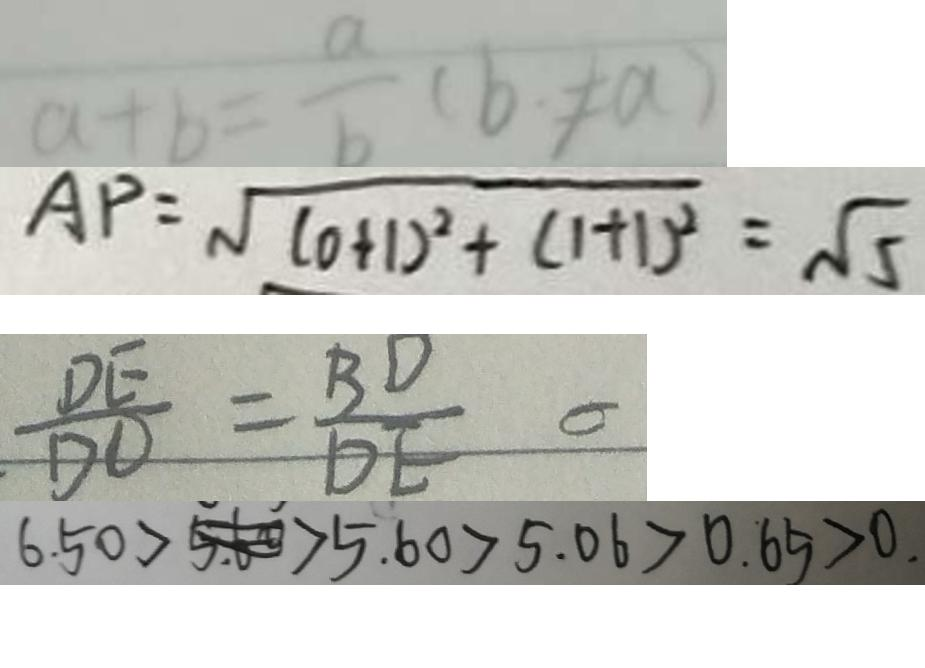Convert formula to latex. <formula><loc_0><loc_0><loc_500><loc_500>a + b = \frac { a } { b } ( b \neq a ) 
 A P = \sqrt { ( 0 + 1 ) ^ { 2 } + ( 1 + 1 ) ^ { 2 } } = \sqrt { 5 } 
 \frac { D E } { D O } = \frac { B D } { D E } 
 6 . 5 0 > 5 . 6 0 > 5 . 0 6 > 0 . 6 5 > 0 .</formula> 